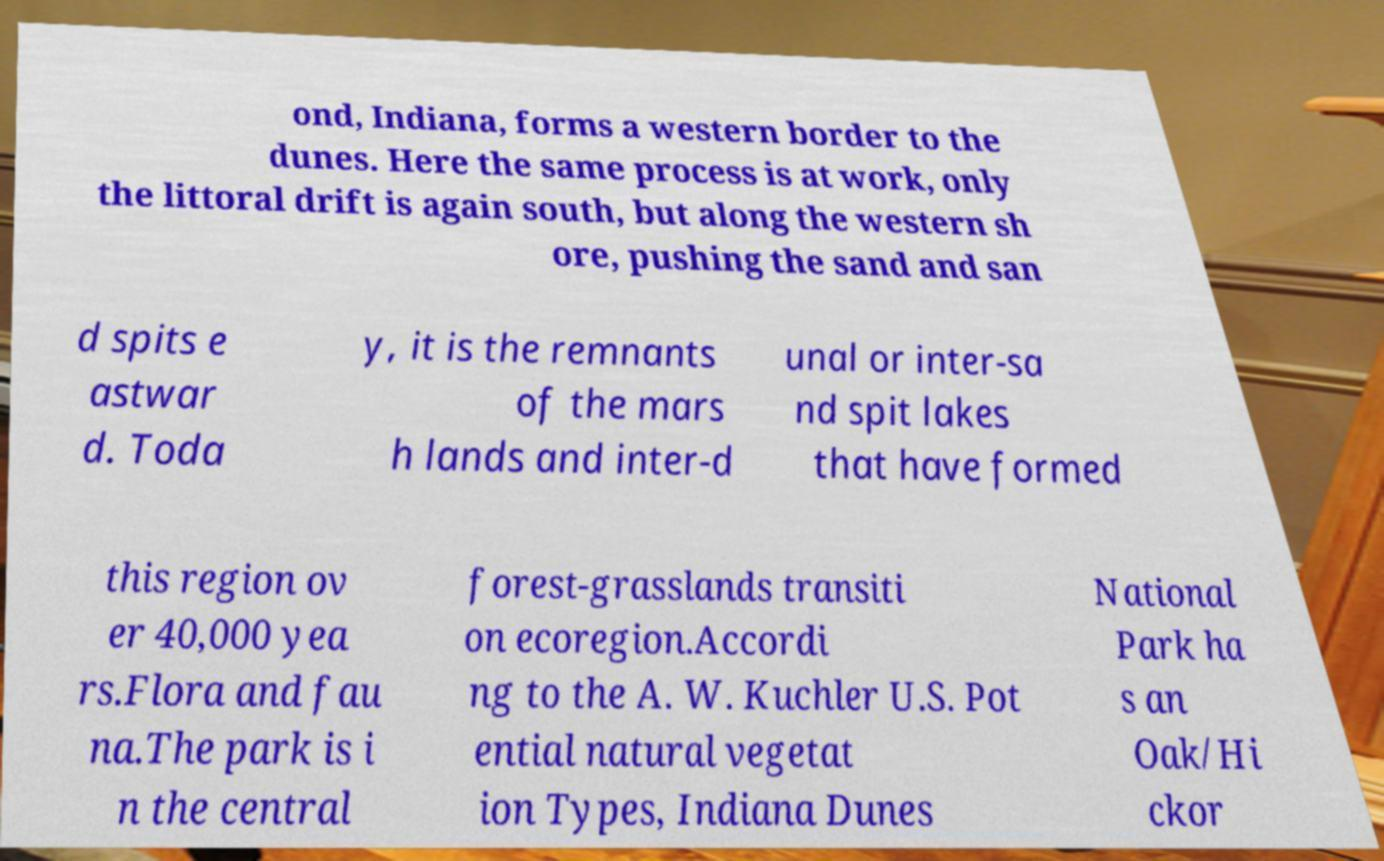I need the written content from this picture converted into text. Can you do that? ond, Indiana, forms a western border to the dunes. Here the same process is at work, only the littoral drift is again south, but along the western sh ore, pushing the sand and san d spits e astwar d. Toda y, it is the remnants of the mars h lands and inter-d unal or inter-sa nd spit lakes that have formed this region ov er 40,000 yea rs.Flora and fau na.The park is i n the central forest-grasslands transiti on ecoregion.Accordi ng to the A. W. Kuchler U.S. Pot ential natural vegetat ion Types, Indiana Dunes National Park ha s an Oak/Hi ckor 